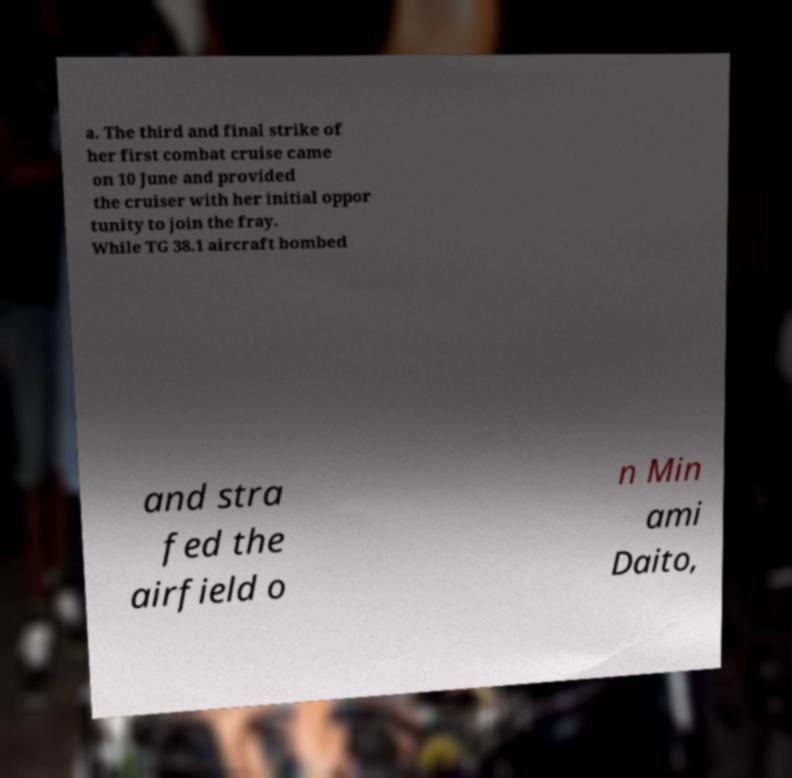Can you accurately transcribe the text from the provided image for me? a. The third and final strike of her first combat cruise came on 10 June and provided the cruiser with her initial oppor tunity to join the fray. While TG 38.1 aircraft bombed and stra fed the airfield o n Min ami Daito, 